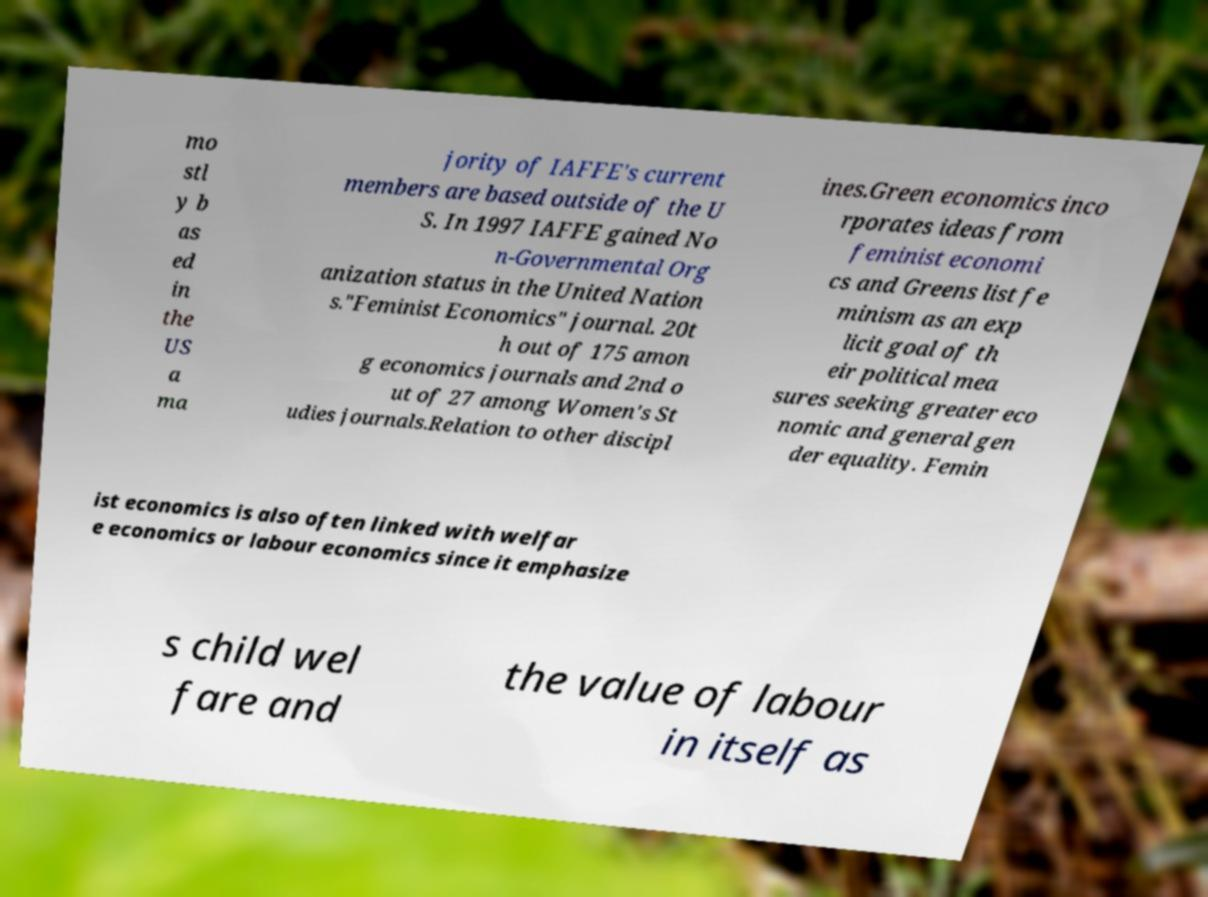Could you assist in decoding the text presented in this image and type it out clearly? mo stl y b as ed in the US a ma jority of IAFFE's current members are based outside of the U S. In 1997 IAFFE gained No n-Governmental Org anization status in the United Nation s."Feminist Economics" journal. 20t h out of 175 amon g economics journals and 2nd o ut of 27 among Women's St udies journals.Relation to other discipl ines.Green economics inco rporates ideas from feminist economi cs and Greens list fe minism as an exp licit goal of th eir political mea sures seeking greater eco nomic and general gen der equality. Femin ist economics is also often linked with welfar e economics or labour economics since it emphasize s child wel fare and the value of labour in itself as 